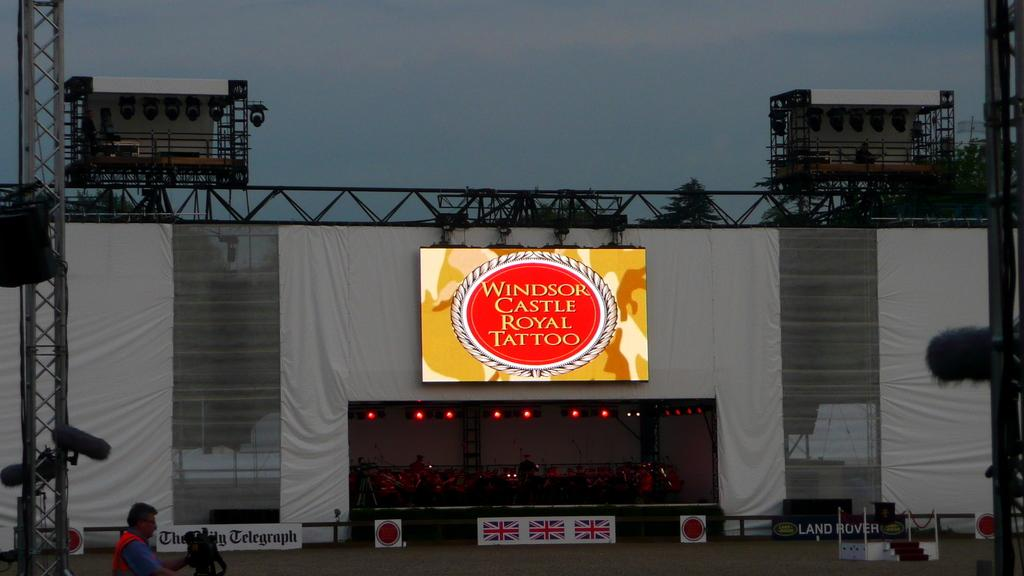Provide a one-sentence caption for the provided image. A sign that says windsor castle royal tattoo. 